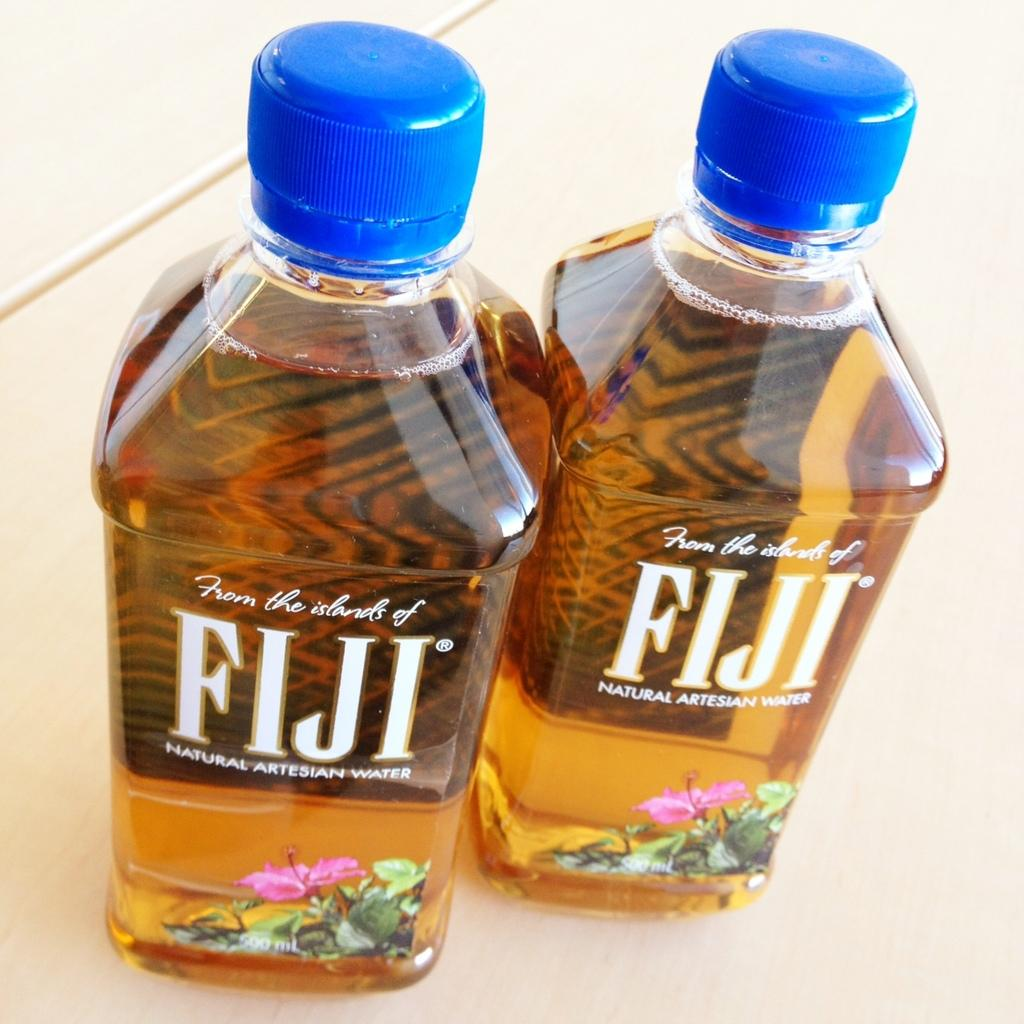<image>
Present a compact description of the photo's key features. Two bottles of golden liquid that read FIJI NATURAL ARTISAN WATER. 